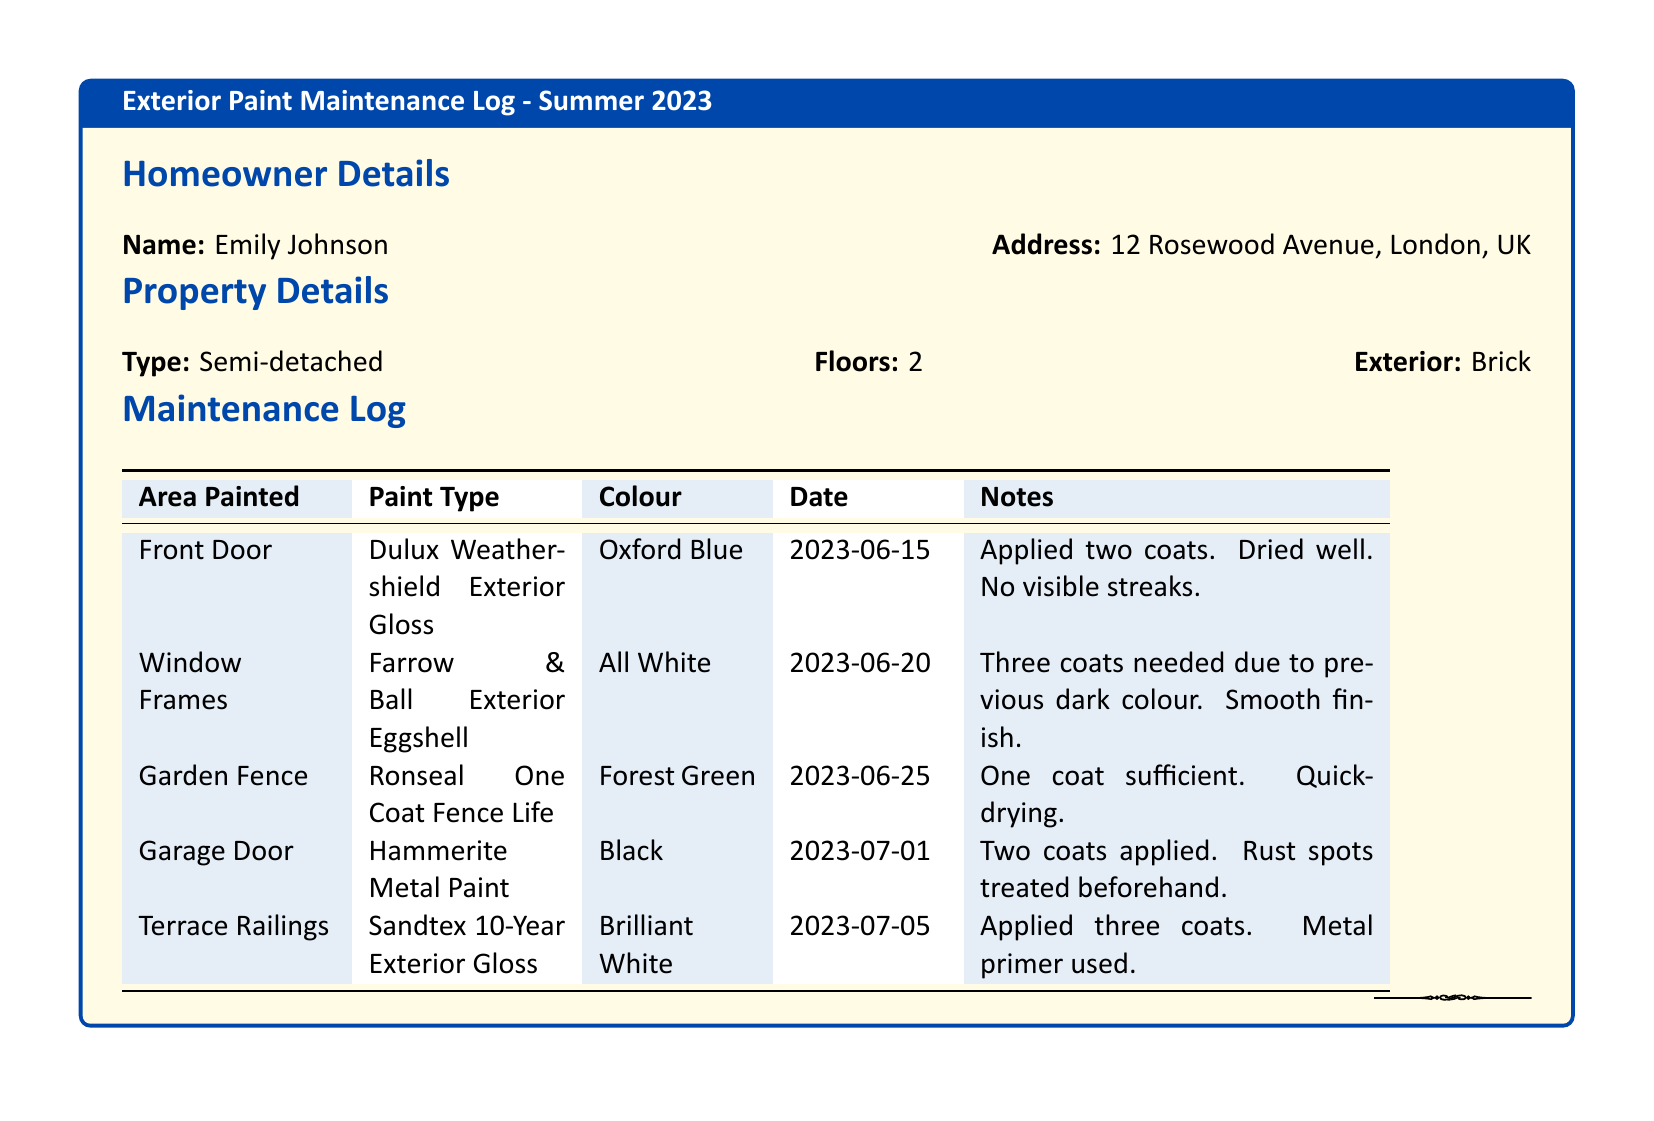What is the name of the homeowner? The homeowner's name is listed in the document's homeowner details section.
Answer: Emily Johnson What is the address of the property? The address is provided in the homeowner details section.
Answer: 12 Rosewood Avenue, London, UK How many coats were applied to the Front Door? The number of coats applied to the Front Door is noted in the maintenance log for that area.
Answer: Two coats What colour was used for the Garage Door? The colour for the Garage Door is specified in the log.
Answer: Black When was the Garden Fence painted? The date for when the Garden Fence was painted is recorded in the maintenance log.
Answer: 2023-06-25 Which paint type was used for the Terrace Railings? The paint type is specified in the maintenance log for the Terrace Railings.
Answer: Sandtex 10-Year Exterior Gloss How many coats were needed for the Window Frames? The number of coats required for the Window Frames is mentioned in the notes section of the log.
Answer: Three coats What type of paint was used for the Garden Fence? The type of paint used for the Garden Fence can be found in the maintenance log.
Answer: Ronseal One Coat Fence Life Which area was painted on July 1st, 2023? The log specifies the areas painted along with their completion dates.
Answer: Garage Door 